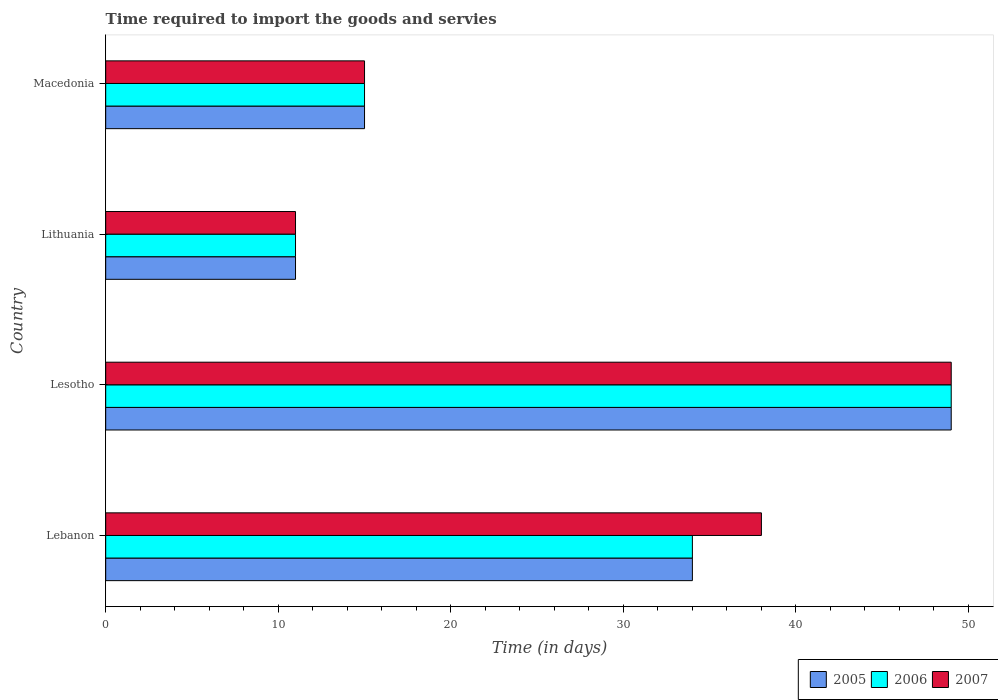Are the number of bars per tick equal to the number of legend labels?
Your response must be concise. Yes. What is the label of the 3rd group of bars from the top?
Provide a short and direct response. Lesotho. In how many cases, is the number of bars for a given country not equal to the number of legend labels?
Ensure brevity in your answer.  0. What is the number of days required to import the goods and services in 2007 in Macedonia?
Your answer should be compact. 15. In which country was the number of days required to import the goods and services in 2005 maximum?
Give a very brief answer. Lesotho. In which country was the number of days required to import the goods and services in 2007 minimum?
Provide a succinct answer. Lithuania. What is the total number of days required to import the goods and services in 2005 in the graph?
Your answer should be compact. 109. What is the average number of days required to import the goods and services in 2006 per country?
Offer a very short reply. 27.25. In how many countries, is the number of days required to import the goods and services in 2006 greater than 26 days?
Give a very brief answer. 2. What is the ratio of the number of days required to import the goods and services in 2007 in Lebanon to that in Macedonia?
Your response must be concise. 2.53. In how many countries, is the number of days required to import the goods and services in 2005 greater than the average number of days required to import the goods and services in 2005 taken over all countries?
Provide a short and direct response. 2. What does the 3rd bar from the top in Lesotho represents?
Make the answer very short. 2005. Is it the case that in every country, the sum of the number of days required to import the goods and services in 2007 and number of days required to import the goods and services in 2006 is greater than the number of days required to import the goods and services in 2005?
Your response must be concise. Yes. Are the values on the major ticks of X-axis written in scientific E-notation?
Offer a terse response. No. How are the legend labels stacked?
Your response must be concise. Horizontal. What is the title of the graph?
Your response must be concise. Time required to import the goods and servies. Does "1973" appear as one of the legend labels in the graph?
Provide a short and direct response. No. What is the label or title of the X-axis?
Ensure brevity in your answer.  Time (in days). What is the Time (in days) of 2005 in Lebanon?
Provide a short and direct response. 34. What is the Time (in days) of 2007 in Lebanon?
Your response must be concise. 38. What is the Time (in days) of 2006 in Lithuania?
Offer a terse response. 11. What is the Time (in days) of 2006 in Macedonia?
Give a very brief answer. 15. Across all countries, what is the maximum Time (in days) in 2005?
Your answer should be compact. 49. Across all countries, what is the maximum Time (in days) of 2007?
Keep it short and to the point. 49. Across all countries, what is the minimum Time (in days) of 2006?
Ensure brevity in your answer.  11. What is the total Time (in days) in 2005 in the graph?
Your answer should be very brief. 109. What is the total Time (in days) of 2006 in the graph?
Ensure brevity in your answer.  109. What is the total Time (in days) of 2007 in the graph?
Provide a short and direct response. 113. What is the difference between the Time (in days) of 2005 in Lebanon and that in Lesotho?
Offer a terse response. -15. What is the difference between the Time (in days) in 2007 in Lebanon and that in Lesotho?
Your answer should be very brief. -11. What is the difference between the Time (in days) in 2005 in Lebanon and that in Lithuania?
Keep it short and to the point. 23. What is the difference between the Time (in days) of 2006 in Lebanon and that in Lithuania?
Provide a short and direct response. 23. What is the difference between the Time (in days) in 2007 in Lebanon and that in Lithuania?
Keep it short and to the point. 27. What is the difference between the Time (in days) in 2005 in Lebanon and that in Macedonia?
Keep it short and to the point. 19. What is the difference between the Time (in days) in 2006 in Lebanon and that in Macedonia?
Keep it short and to the point. 19. What is the difference between the Time (in days) in 2007 in Lebanon and that in Macedonia?
Your answer should be very brief. 23. What is the difference between the Time (in days) in 2006 in Lesotho and that in Lithuania?
Provide a short and direct response. 38. What is the difference between the Time (in days) in 2007 in Lesotho and that in Lithuania?
Provide a short and direct response. 38. What is the difference between the Time (in days) of 2005 in Lesotho and that in Macedonia?
Provide a short and direct response. 34. What is the difference between the Time (in days) in 2007 in Lesotho and that in Macedonia?
Ensure brevity in your answer.  34. What is the difference between the Time (in days) of 2005 in Lithuania and that in Macedonia?
Your response must be concise. -4. What is the difference between the Time (in days) in 2005 in Lebanon and the Time (in days) in 2006 in Lesotho?
Offer a very short reply. -15. What is the difference between the Time (in days) of 2005 in Lebanon and the Time (in days) of 2007 in Lesotho?
Offer a terse response. -15. What is the difference between the Time (in days) of 2005 in Lebanon and the Time (in days) of 2006 in Lithuania?
Provide a succinct answer. 23. What is the difference between the Time (in days) of 2005 in Lebanon and the Time (in days) of 2007 in Lithuania?
Your response must be concise. 23. What is the difference between the Time (in days) in 2006 in Lebanon and the Time (in days) in 2007 in Lithuania?
Your answer should be very brief. 23. What is the difference between the Time (in days) in 2005 in Lebanon and the Time (in days) in 2006 in Macedonia?
Give a very brief answer. 19. What is the difference between the Time (in days) in 2005 in Lebanon and the Time (in days) in 2007 in Macedonia?
Provide a short and direct response. 19. What is the difference between the Time (in days) in 2006 in Lebanon and the Time (in days) in 2007 in Macedonia?
Provide a short and direct response. 19. What is the difference between the Time (in days) of 2005 in Lesotho and the Time (in days) of 2006 in Lithuania?
Make the answer very short. 38. What is the difference between the Time (in days) in 2005 in Lesotho and the Time (in days) in 2006 in Macedonia?
Give a very brief answer. 34. What is the difference between the Time (in days) in 2006 in Lesotho and the Time (in days) in 2007 in Macedonia?
Make the answer very short. 34. What is the difference between the Time (in days) of 2005 in Lithuania and the Time (in days) of 2006 in Macedonia?
Your response must be concise. -4. What is the difference between the Time (in days) in 2005 in Lithuania and the Time (in days) in 2007 in Macedonia?
Provide a short and direct response. -4. What is the difference between the Time (in days) of 2006 in Lithuania and the Time (in days) of 2007 in Macedonia?
Make the answer very short. -4. What is the average Time (in days) of 2005 per country?
Give a very brief answer. 27.25. What is the average Time (in days) of 2006 per country?
Your answer should be very brief. 27.25. What is the average Time (in days) of 2007 per country?
Provide a succinct answer. 28.25. What is the difference between the Time (in days) of 2005 and Time (in days) of 2006 in Lebanon?
Make the answer very short. 0. What is the difference between the Time (in days) in 2005 and Time (in days) in 2006 in Lesotho?
Provide a succinct answer. 0. What is the difference between the Time (in days) in 2006 and Time (in days) in 2007 in Lesotho?
Your answer should be compact. 0. What is the difference between the Time (in days) of 2005 and Time (in days) of 2006 in Lithuania?
Provide a succinct answer. 0. What is the ratio of the Time (in days) in 2005 in Lebanon to that in Lesotho?
Your answer should be compact. 0.69. What is the ratio of the Time (in days) in 2006 in Lebanon to that in Lesotho?
Provide a succinct answer. 0.69. What is the ratio of the Time (in days) in 2007 in Lebanon to that in Lesotho?
Provide a short and direct response. 0.78. What is the ratio of the Time (in days) in 2005 in Lebanon to that in Lithuania?
Make the answer very short. 3.09. What is the ratio of the Time (in days) in 2006 in Lebanon to that in Lithuania?
Your answer should be very brief. 3.09. What is the ratio of the Time (in days) in 2007 in Lebanon to that in Lithuania?
Offer a terse response. 3.45. What is the ratio of the Time (in days) in 2005 in Lebanon to that in Macedonia?
Provide a short and direct response. 2.27. What is the ratio of the Time (in days) in 2006 in Lebanon to that in Macedonia?
Give a very brief answer. 2.27. What is the ratio of the Time (in days) in 2007 in Lebanon to that in Macedonia?
Your response must be concise. 2.53. What is the ratio of the Time (in days) of 2005 in Lesotho to that in Lithuania?
Make the answer very short. 4.45. What is the ratio of the Time (in days) in 2006 in Lesotho to that in Lithuania?
Give a very brief answer. 4.45. What is the ratio of the Time (in days) of 2007 in Lesotho to that in Lithuania?
Make the answer very short. 4.45. What is the ratio of the Time (in days) of 2005 in Lesotho to that in Macedonia?
Give a very brief answer. 3.27. What is the ratio of the Time (in days) of 2006 in Lesotho to that in Macedonia?
Your answer should be compact. 3.27. What is the ratio of the Time (in days) in 2007 in Lesotho to that in Macedonia?
Give a very brief answer. 3.27. What is the ratio of the Time (in days) of 2005 in Lithuania to that in Macedonia?
Provide a short and direct response. 0.73. What is the ratio of the Time (in days) of 2006 in Lithuania to that in Macedonia?
Your answer should be very brief. 0.73. What is the ratio of the Time (in days) of 2007 in Lithuania to that in Macedonia?
Offer a terse response. 0.73. What is the difference between the highest and the second highest Time (in days) in 2007?
Provide a short and direct response. 11. What is the difference between the highest and the lowest Time (in days) of 2005?
Provide a succinct answer. 38. What is the difference between the highest and the lowest Time (in days) of 2006?
Offer a very short reply. 38. 